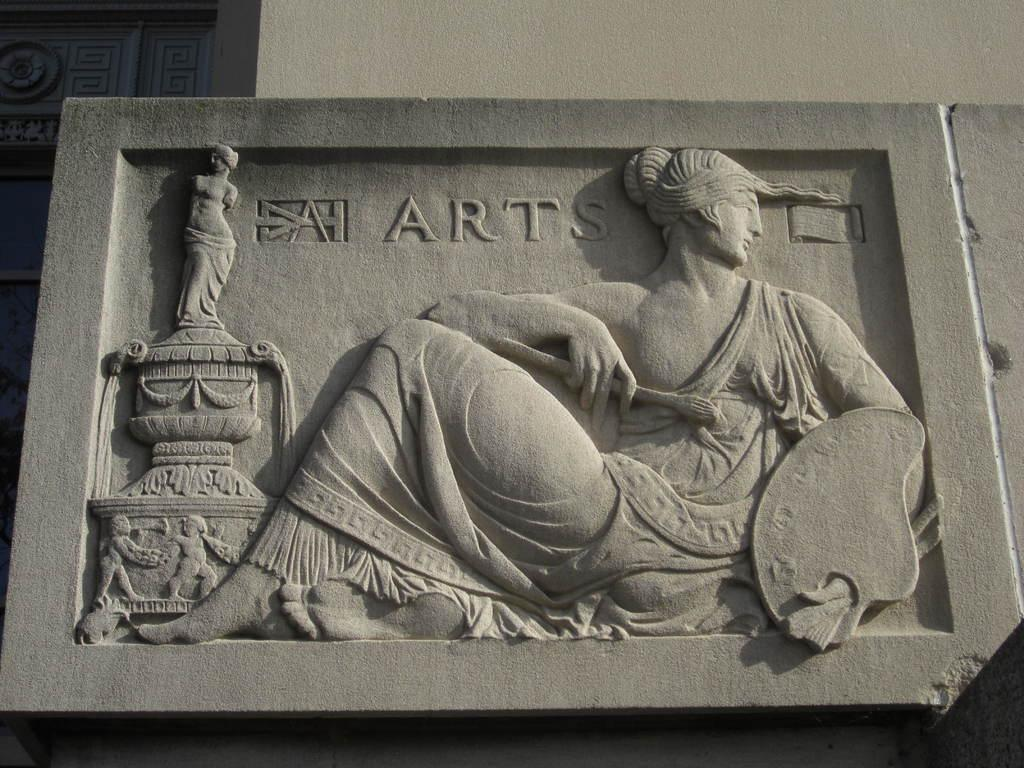What is on the wall in the image? There is a sculpture on the wall in the image. What type of impulse can be seen affecting the sculpture in the image? There is no impulse affecting the sculpture in the image; it is stationary on the wall. Is there a dock visible in the image? There is no dock present in the image. 